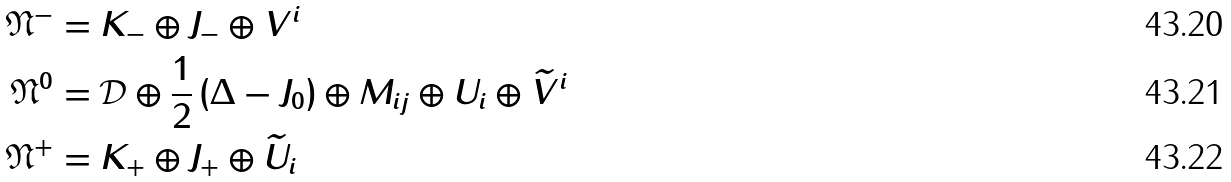Convert formula to latex. <formula><loc_0><loc_0><loc_500><loc_500>\mathfrak { N } ^ { - } & = K _ { - } \oplus J _ { - } \oplus V ^ { i } \\ \mathfrak { N } ^ { 0 } & = \mathcal { D } \oplus \frac { 1 } { 2 } \left ( \Delta - J _ { 0 } \right ) \oplus M _ { i j } \oplus U _ { i } \oplus \widetilde { V } ^ { i } \\ \mathfrak { N } ^ { + } & = K _ { + } \oplus J _ { + } \oplus \widetilde { U } _ { i }</formula> 